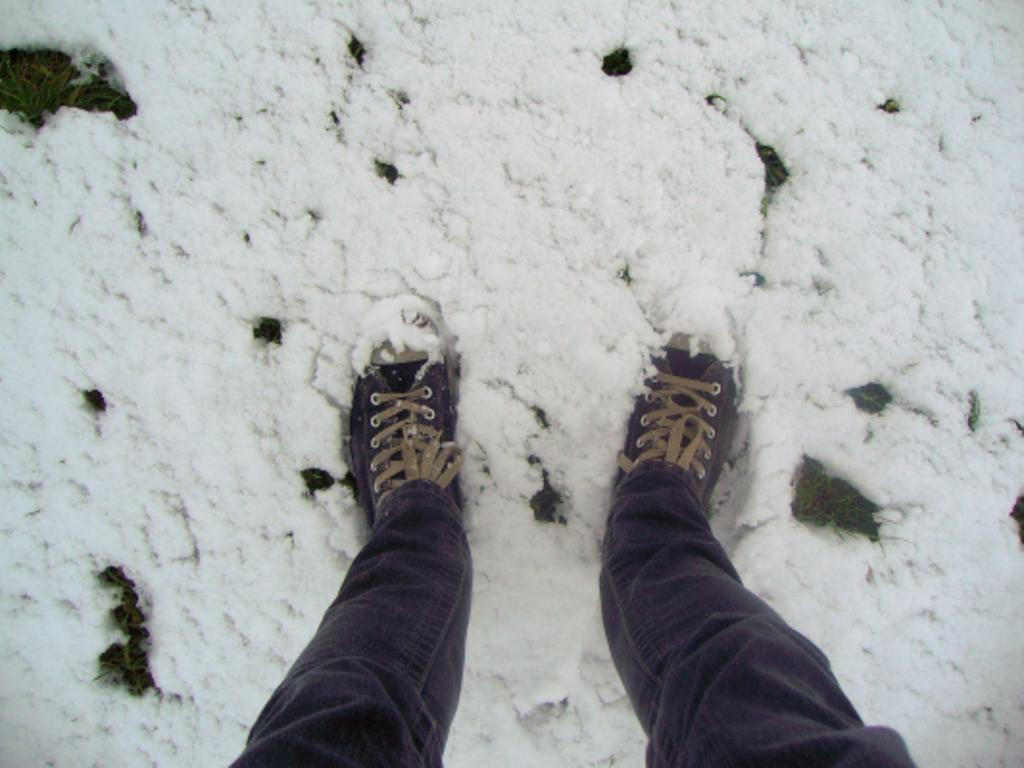What is covering the ground in the image? There is snow on the ground in the image. What part of a person can be seen in the image? The legs of a person are visible in the image. What type of clothing is the person wearing on their legs? The person is wearing jeans. What type of footwear is the person wearing? The person is wearing shoes. What type of stamp can be seen on the person's jeans in the image? There is no stamp visible on the person's jeans in the image. 